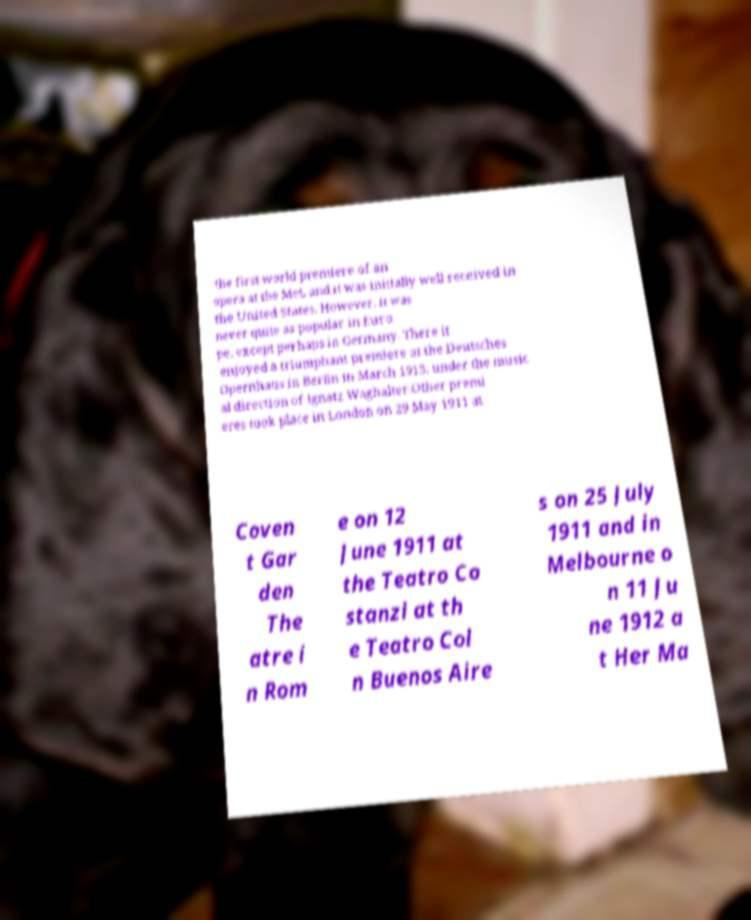Can you read and provide the text displayed in the image?This photo seems to have some interesting text. Can you extract and type it out for me? the first world premiere of an opera at the Met, and it was initially well received in the United States. However, it was never quite as popular in Euro pe, except perhaps in Germany. There it enjoyed a triumphant premiere at the Deutsches Opernhaus in Berlin in March 1913, under the music al direction of Ignatz Waghalter.Other premi eres took place in London on 29 May 1911 at Coven t Gar den The atre i n Rom e on 12 June 1911 at the Teatro Co stanzi at th e Teatro Col n Buenos Aire s on 25 July 1911 and in Melbourne o n 11 Ju ne 1912 a t Her Ma 